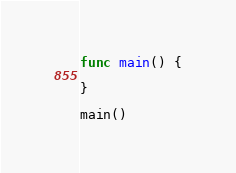Convert code to text. <code><loc_0><loc_0><loc_500><loc_500><_Swift_>func main() {
	
}

main()
</code> 